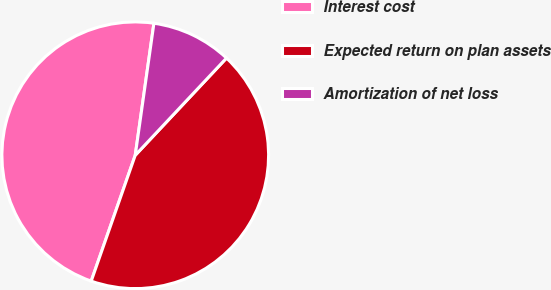Convert chart to OTSL. <chart><loc_0><loc_0><loc_500><loc_500><pie_chart><fcel>Interest cost<fcel>Expected return on plan assets<fcel>Amortization of net loss<nl><fcel>46.88%<fcel>43.36%<fcel>9.76%<nl></chart> 